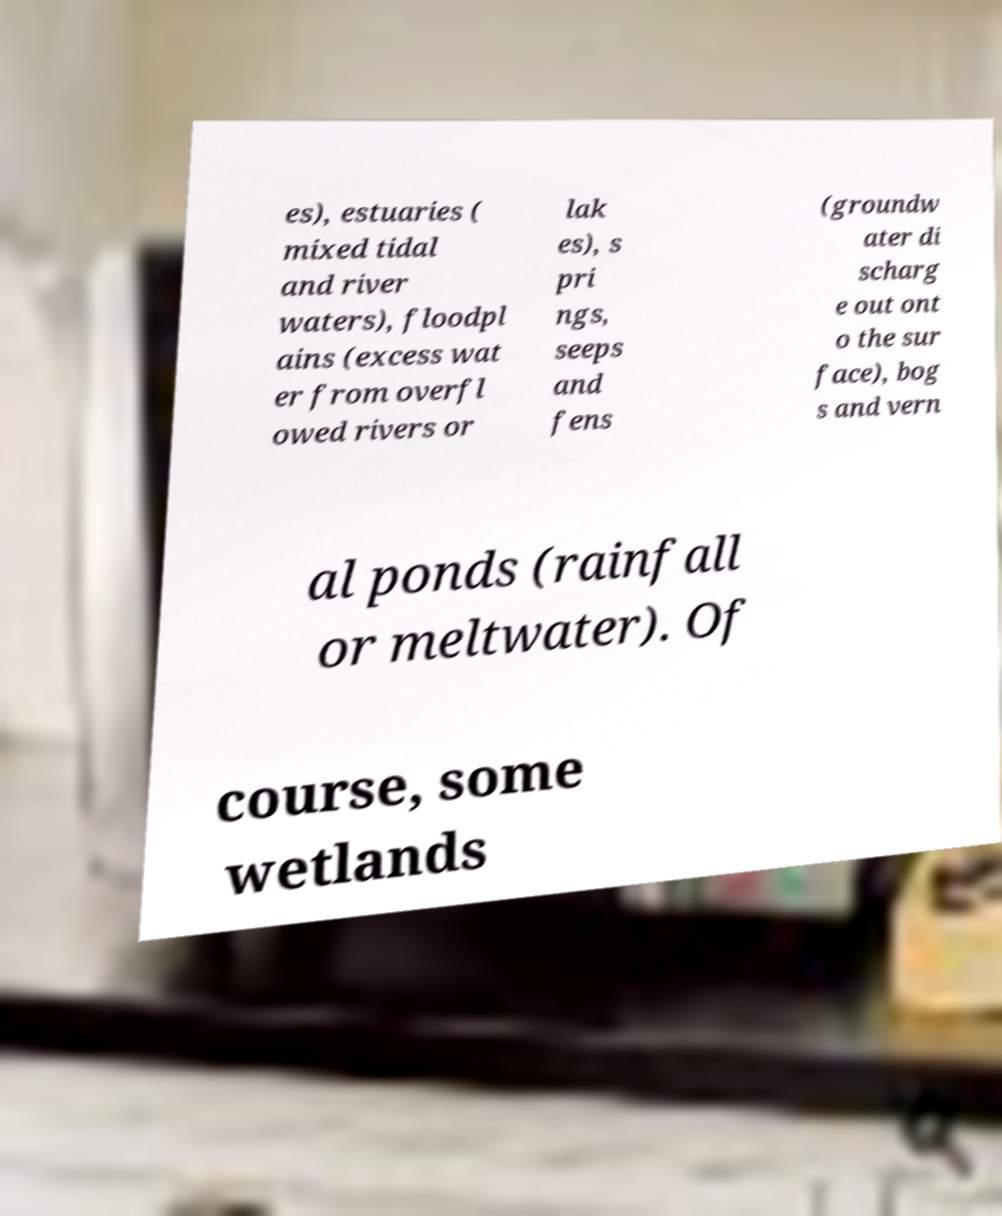I need the written content from this picture converted into text. Can you do that? es), estuaries ( mixed tidal and river waters), floodpl ains (excess wat er from overfl owed rivers or lak es), s pri ngs, seeps and fens (groundw ater di scharg e out ont o the sur face), bog s and vern al ponds (rainfall or meltwater). Of course, some wetlands 